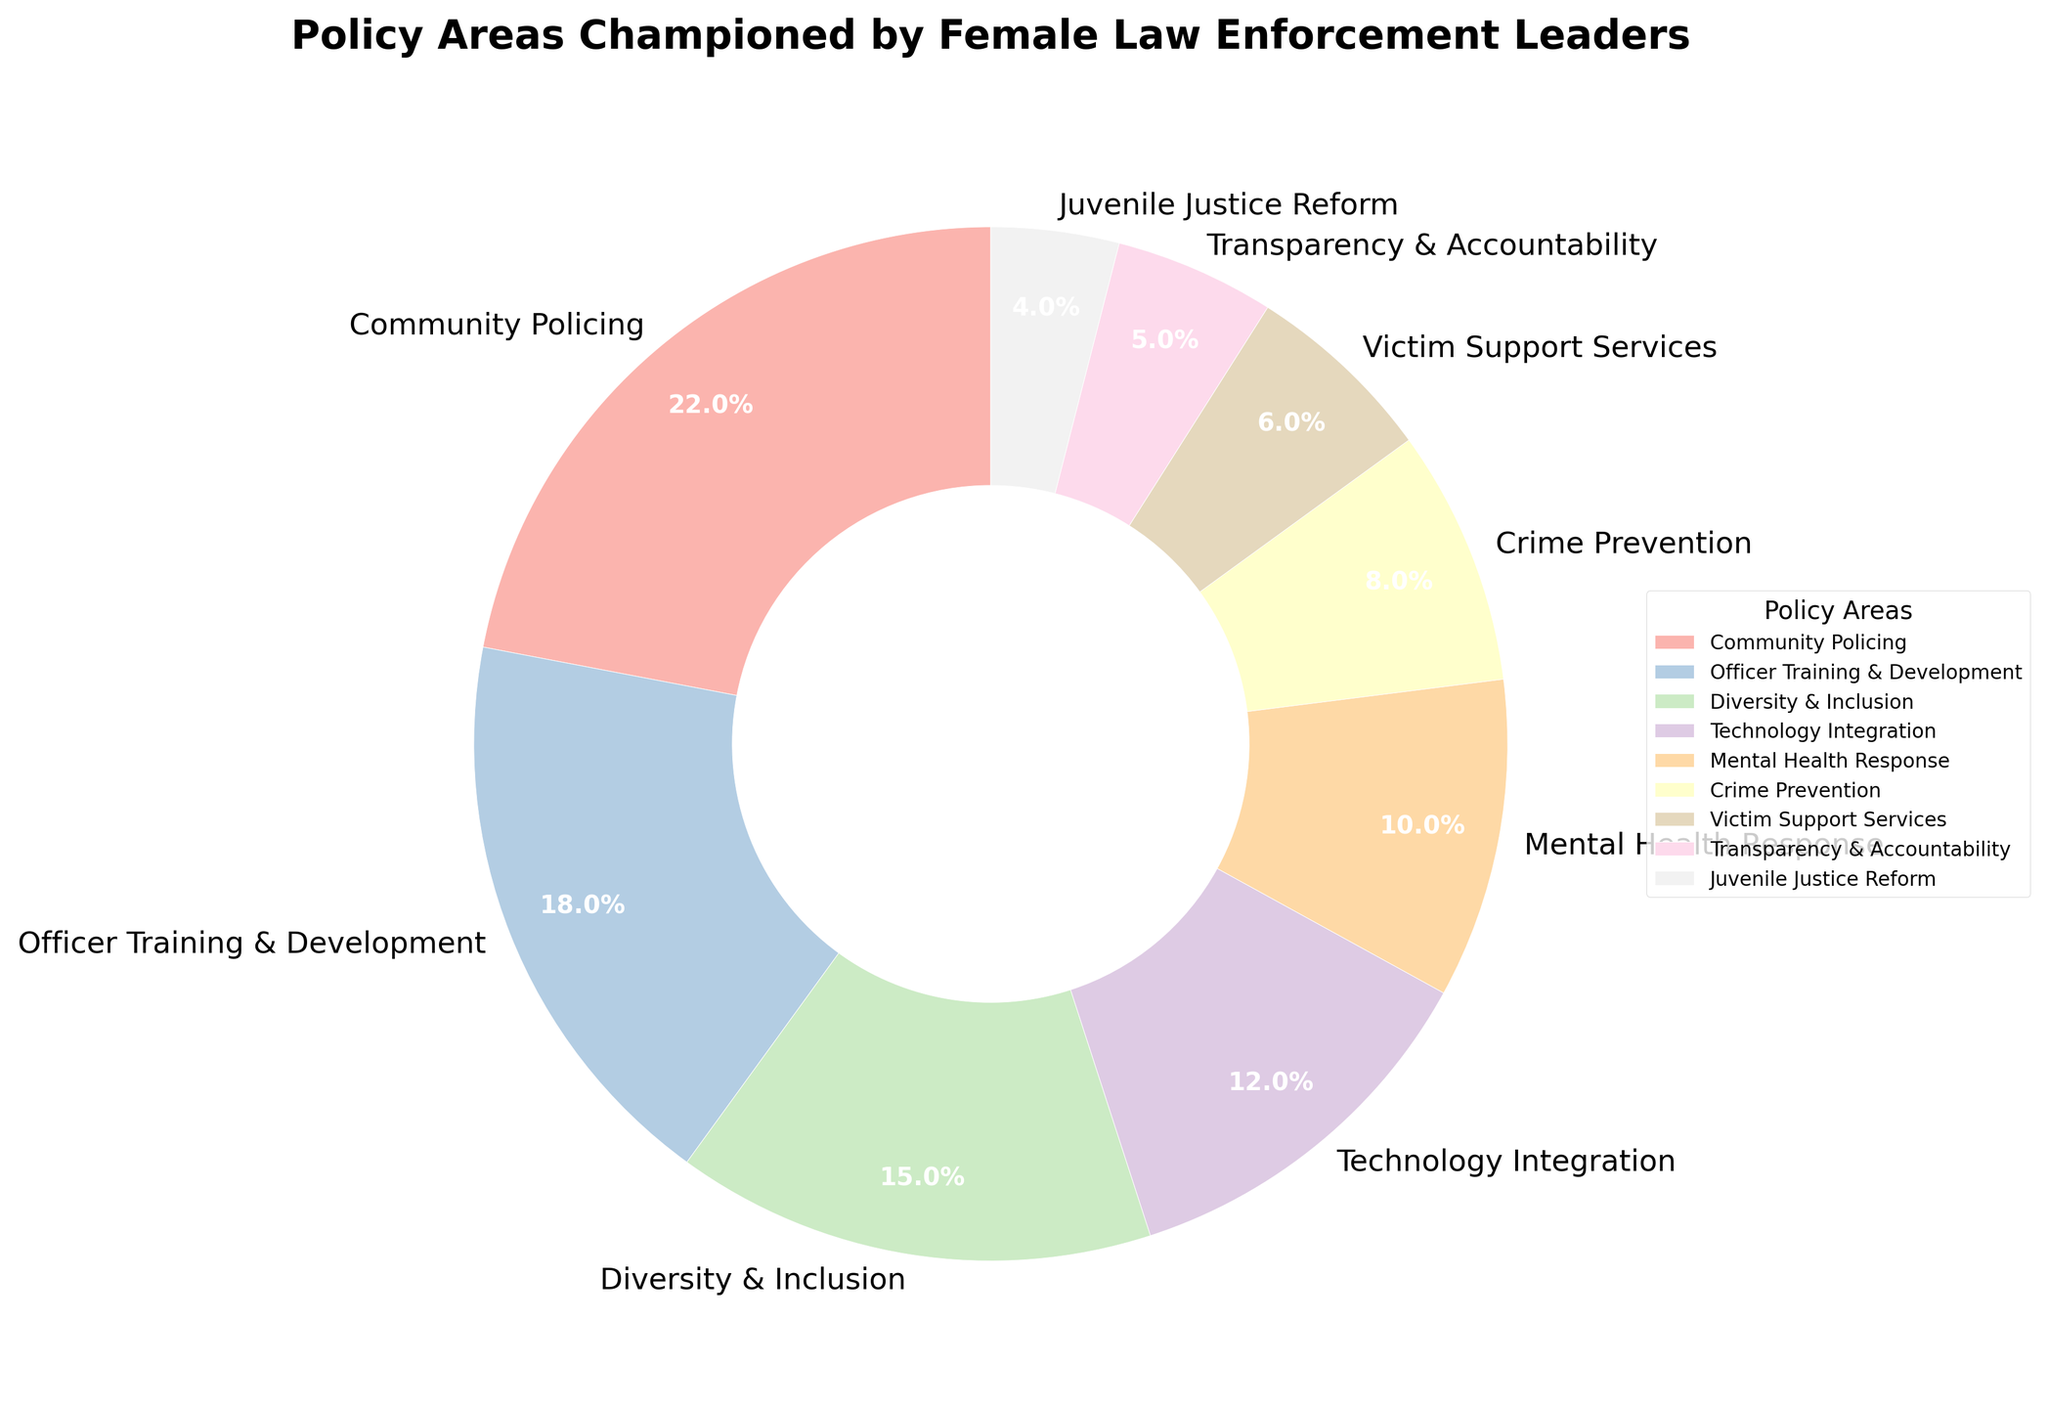What percentage of policy areas championed by female law enforcement leaders is dedicated to Community Policing? According to the figure, Community Policing is allocated a percentage in the pie chart. One can read directly from the chart that Community Policing is represented by 22%.
Answer: 22% Which policy area has the smallest percentage, and what is that percentage? By looking at the pie chart's segments and corresponding values, Juvenile Justice Reform occupies the smallest segment, indicating it has the smallest percentage, which is 4%.
Answer: Juvenile Justice Reform, 4% How do the combined percentages of Officer Training & Development and Diversity & Inclusion compare to the percentage for Community Policing? The percentages for Officer Training & Development and Diversity & Inclusion are 18% and 15%, respectively. Summing these two gives 18% + 15% = 33%. Comparing this to Community Policing, which is 22%, 33% is larger.
Answer: Combined percentage (33%) is greater than Community Policing (22%) What is the total percentage for the policy areas related to mental health (Mental Health Response) and victim support (Victim Support Services)? The percentage for Mental Health Response is 10%, and for Victim Support Services, it is 6%. Adding these two together gives 10% + 6% = 16%.
Answer: 16% Which policy area excluding Community Policing has the highest percentage and what is it? From the pie chart, excluding Community Policing, Officer Training & Development shows the next largest segment with 18%.
Answer: Officer Training & Development, 18% By how much does the percentage of Diversity & Inclusion exceed Juvenile Justice Reform? The percentage for Diversity & Inclusion is 15% and for Juvenile Justice Reform, it is 4%. The difference is calculated as 15% - 4% = 11%.
Answer: 11% Rank the top three policy areas in descending order of their percentage representation. By observing the pie chart, the top three policy areas are Community Policing (22%), Officer Training & Development (18%), and Diversity & Inclusion (15%).
Answer: Community Policing, Officer Training & Development, Diversity & Inclusion What is the combined percentage for the areas related to integration (Technology Integration) and accountability (Transparency & Accountability)? The chart values for Technology Integration and Transparency & Accountability are 12% and 5%, respectively. Summing these gives 12% + 5% = 17%.
Answer: 17% What is the average percentage representation of the policy areas Crime Prevention, Victim Support Services, and Transparency & Accountability? The individual percentages for Crime Prevention, Victim Support Services, and Transparency & Accountability are 8%, 6%, and 5%, respectively. Summing these gives 8% + 6% + 5% = 19% and then averaging it out (19% / 3) results in approximately 6.33%.
Answer: 6.33% Among the areas listed, which policy area related to policing has a middle (median) position in terms of percentage representation? Arranging the percentages in ascending order: 4%, 5%, 6%, 8%, 10%, 12%, 15%, 18%, 22%. The median is the middle value which is 10% for Mental Health Response.
Answer: Mental Health Response 